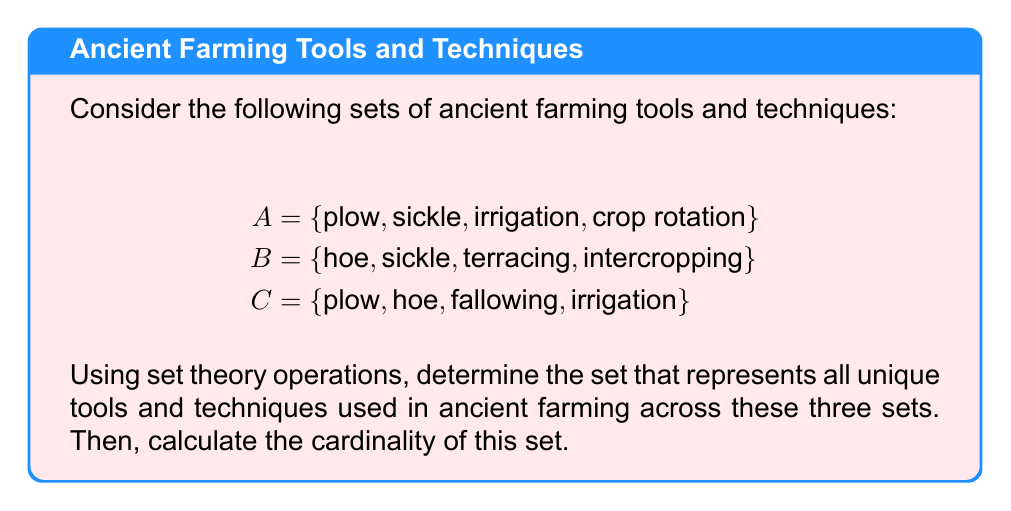Could you help me with this problem? To solve this problem, we'll follow these steps:

1) First, we need to find the union of all three sets. The union operation (∪) combines all unique elements from the given sets.

   $$ A \cup B \cup C $$

2) Let's list out all unique elements:
   {plow, sickle, irrigation, crop rotation, hoe, terracing, intercropping, fallowing}

3) Now, we need to count the number of elements in this set. In set theory, this is called the cardinality of the set, denoted by vertical bars | |.

4) Counting the elements:
   - plow
   - sickle
   - irrigation
   - crop rotation
   - hoe
   - terracing
   - intercropping
   - fallowing

5) The total count is 8.

Therefore, the cardinality of the set of all unique tools and techniques is:

   $$ |A \cup B \cup C| = 8 $$

This result shows that across these three sets, there are 8 unique ancient farming tools and techniques.
Answer: 8 